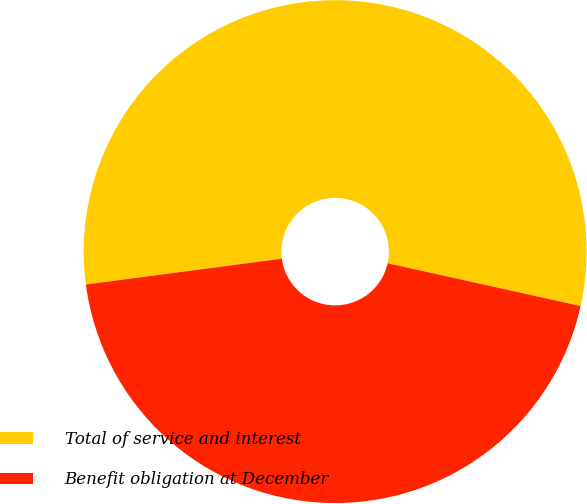<chart> <loc_0><loc_0><loc_500><loc_500><pie_chart><fcel>Total of service and interest<fcel>Benefit obligation at December<nl><fcel>55.56%<fcel>44.44%<nl></chart> 